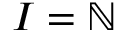<formula> <loc_0><loc_0><loc_500><loc_500>I = \mathbb { N }</formula> 